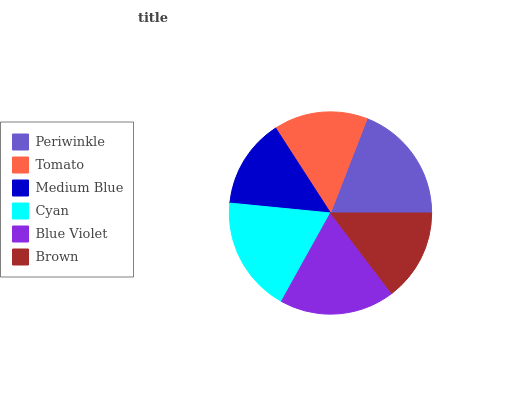Is Medium Blue the minimum?
Answer yes or no. Yes. Is Periwinkle the maximum?
Answer yes or no. Yes. Is Tomato the minimum?
Answer yes or no. No. Is Tomato the maximum?
Answer yes or no. No. Is Periwinkle greater than Tomato?
Answer yes or no. Yes. Is Tomato less than Periwinkle?
Answer yes or no. Yes. Is Tomato greater than Periwinkle?
Answer yes or no. No. Is Periwinkle less than Tomato?
Answer yes or no. No. Is Blue Violet the high median?
Answer yes or no. Yes. Is Tomato the low median?
Answer yes or no. Yes. Is Medium Blue the high median?
Answer yes or no. No. Is Brown the low median?
Answer yes or no. No. 